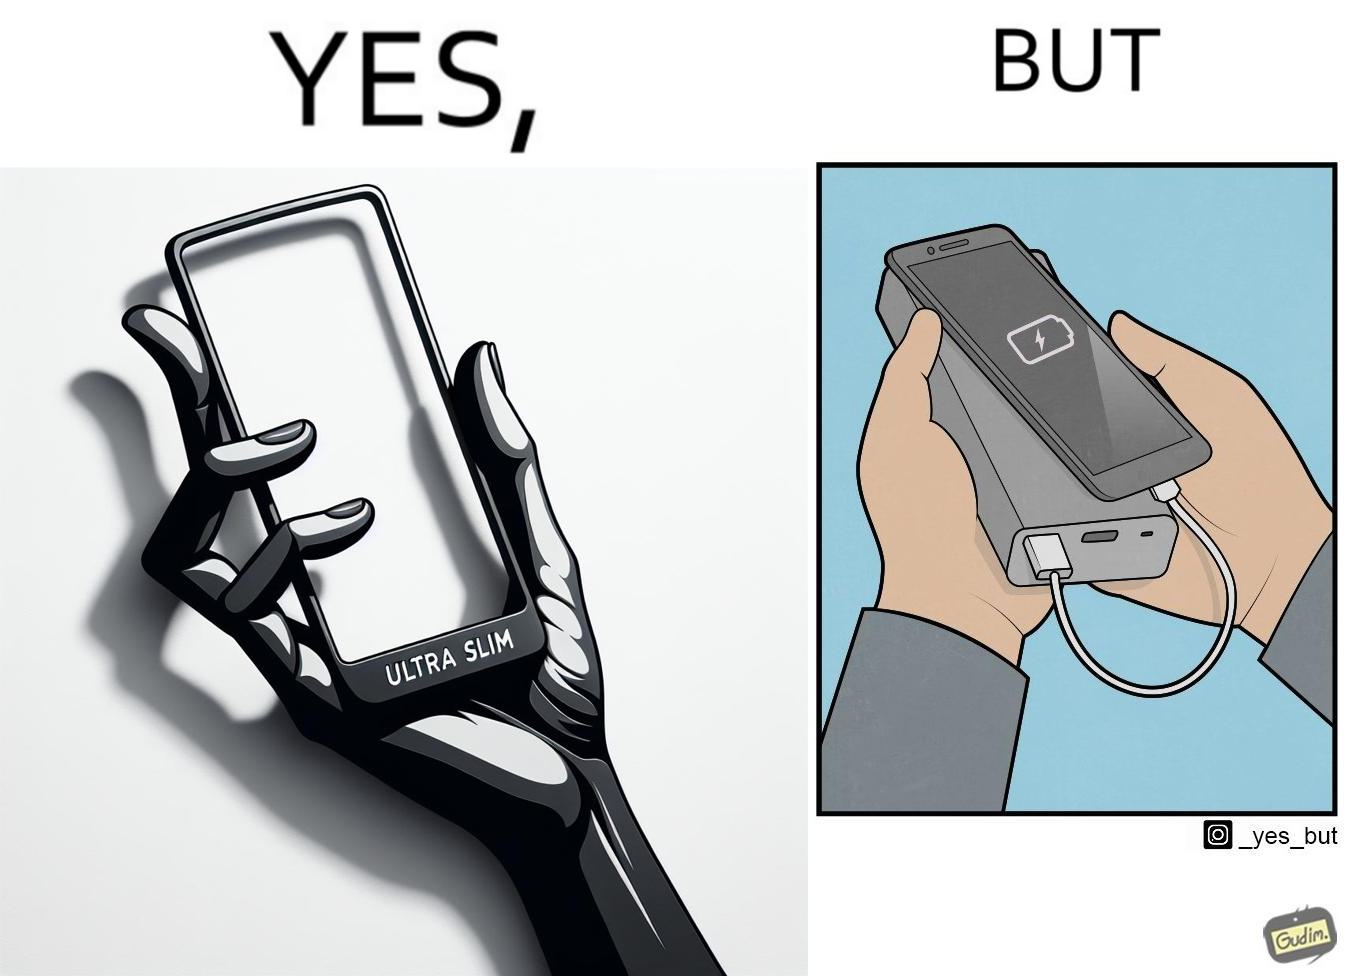Compare the left and right sides of this image. In the left part of the image: The image shows a hand holding a mobile phone with finger tips. The text on the screen of the mobile phone says "ULTRA SLIM".  The mobile phone is indeed very slim. In the right part of the image: The image shows a slim mobile phone connected to a thick,big and heavy power bank for charging the mobile phone. 